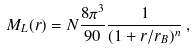Convert formula to latex. <formula><loc_0><loc_0><loc_500><loc_500>M _ { L } ( r ) = N \frac { 8 \pi ^ { 3 } } { 9 0 } \frac { 1 } { ( 1 + r / r _ { B } ) ^ { n } } \, ,</formula> 